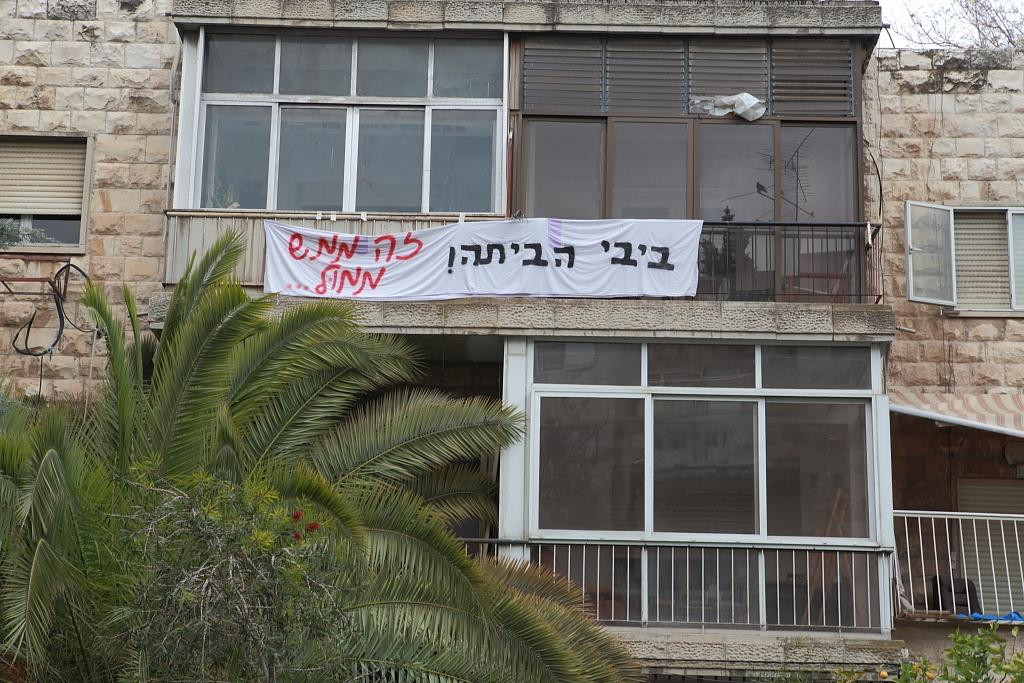What type of structure is present in the image? There is a building in the image. What can be seen in the background of the image? There are trees in the image. What feature allows light to enter the building? There are windows in the image. What type of cooking equipment is visible in the image? There are grills in the image. What is written or displayed on a surface in the image? There is a poster with text in the image. What is visible above the building and trees? The sky is visible in the image. What type of cloth is being used to cover the grills in the image? There is no cloth present in the image, and the grills are not covered. 